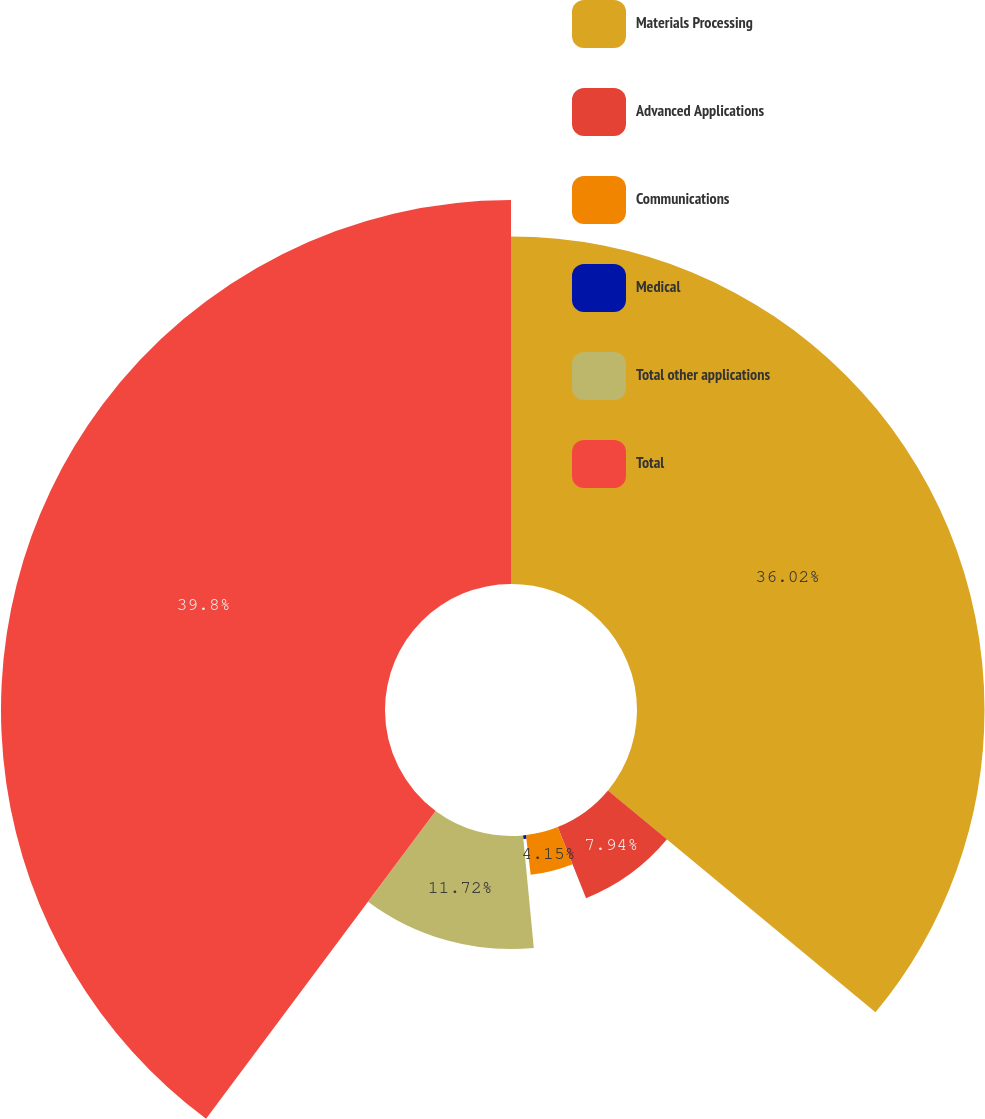Convert chart. <chart><loc_0><loc_0><loc_500><loc_500><pie_chart><fcel>Materials Processing<fcel>Advanced Applications<fcel>Communications<fcel>Medical<fcel>Total other applications<fcel>Total<nl><fcel>36.02%<fcel>7.94%<fcel>4.15%<fcel>0.37%<fcel>11.72%<fcel>39.8%<nl></chart> 